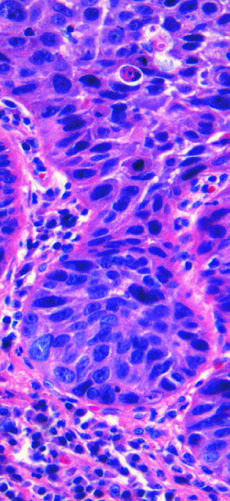s low magnification composed of nests of malignant cells that partially recapitulate the stratified organization of squamous epithelium?
Answer the question using a single word or phrase. No 